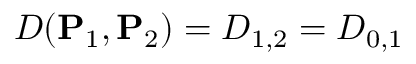Convert formula to latex. <formula><loc_0><loc_0><loc_500><loc_500>D ( P _ { 1 } , P _ { 2 } ) = D _ { 1 , 2 } = D _ { 0 , 1 }</formula> 